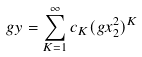<formula> <loc_0><loc_0><loc_500><loc_500>g y = \sum _ { K = 1 } ^ { \infty } c _ { K } ( g x _ { 2 } ^ { 2 } ) ^ { K }</formula> 